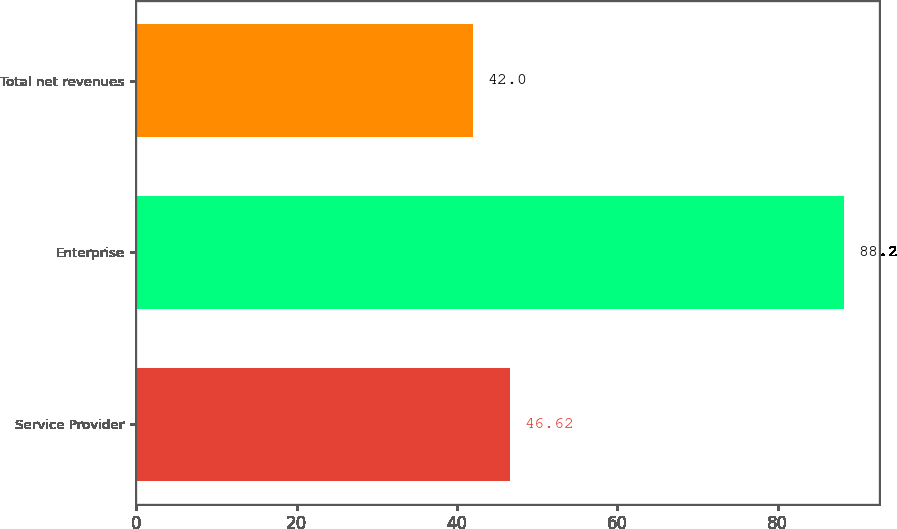<chart> <loc_0><loc_0><loc_500><loc_500><bar_chart><fcel>Service Provider<fcel>Enterprise<fcel>Total net revenues<nl><fcel>46.62<fcel>88.2<fcel>42<nl></chart> 